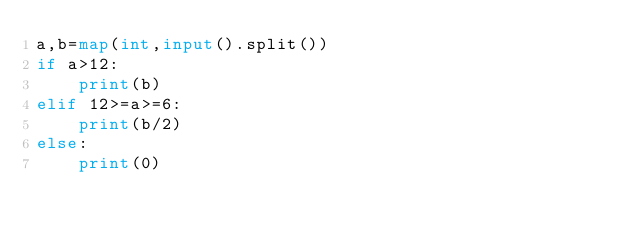Convert code to text. <code><loc_0><loc_0><loc_500><loc_500><_Python_>a,b=map(int,input().split())
if a>12:
    print(b)
elif 12>=a>=6:
    print(b/2)
else:
    print(0)
</code> 